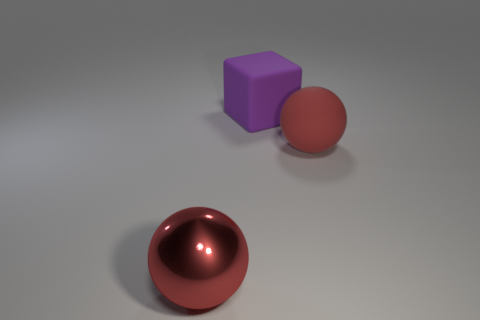Is the metal thing the same color as the matte sphere?
Your answer should be compact. Yes. There is a big object that is both behind the big metal ball and in front of the purple matte block; what is its shape?
Ensure brevity in your answer.  Sphere. Is there a big object of the same color as the large metallic ball?
Make the answer very short. Yes. There is a big rubber object to the left of the large object to the right of the matte block; what is its color?
Your response must be concise. Purple. Does the large purple block have the same material as the large red thing that is on the left side of the big purple rubber cube?
Ensure brevity in your answer.  No. Are there any other large cyan things of the same shape as the big shiny thing?
Keep it short and to the point. No. How many things are large red balls on the right side of the rubber cube or large purple rubber things?
Your answer should be very brief. 2. There is a object that is the same color as the big rubber ball; what size is it?
Give a very brief answer. Large. Do the sphere on the right side of the red metal thing and the ball in front of the red rubber sphere have the same color?
Give a very brief answer. Yes. The purple block is what size?
Ensure brevity in your answer.  Large. 